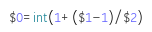<code> <loc_0><loc_0><loc_500><loc_500><_Awk_>$0=int(1+($1-1)/$2)</code> 